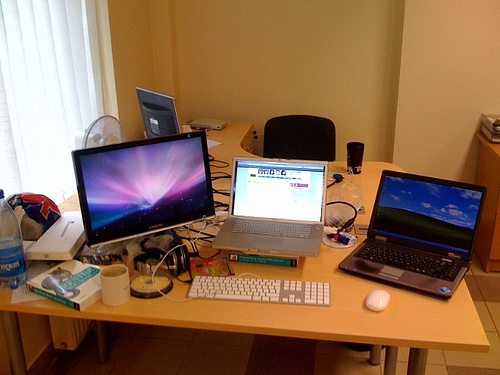Describe the objects in this image and their specific colors. I can see laptop in lightblue, black, navy, maroon, and darkblue tones, tv in lightblue, black, purple, and violet tones, laptop in lightblue, white, gray, and brown tones, keyboard in lightblue, tan, and gray tones, and chair in lightblue, black, maroon, and olive tones in this image. 